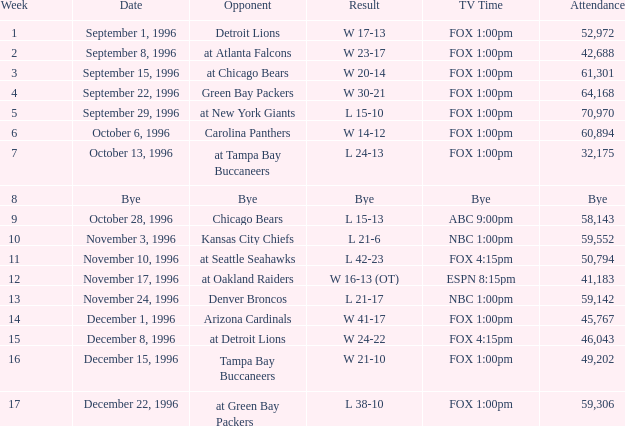Tell me the tv time for attendance of 60,894 FOX 1:00pm. 